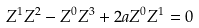<formula> <loc_0><loc_0><loc_500><loc_500>Z ^ { 1 } Z ^ { 2 } - Z ^ { 0 } Z ^ { 3 } + 2 a Z ^ { 0 } Z ^ { 1 } = 0</formula> 